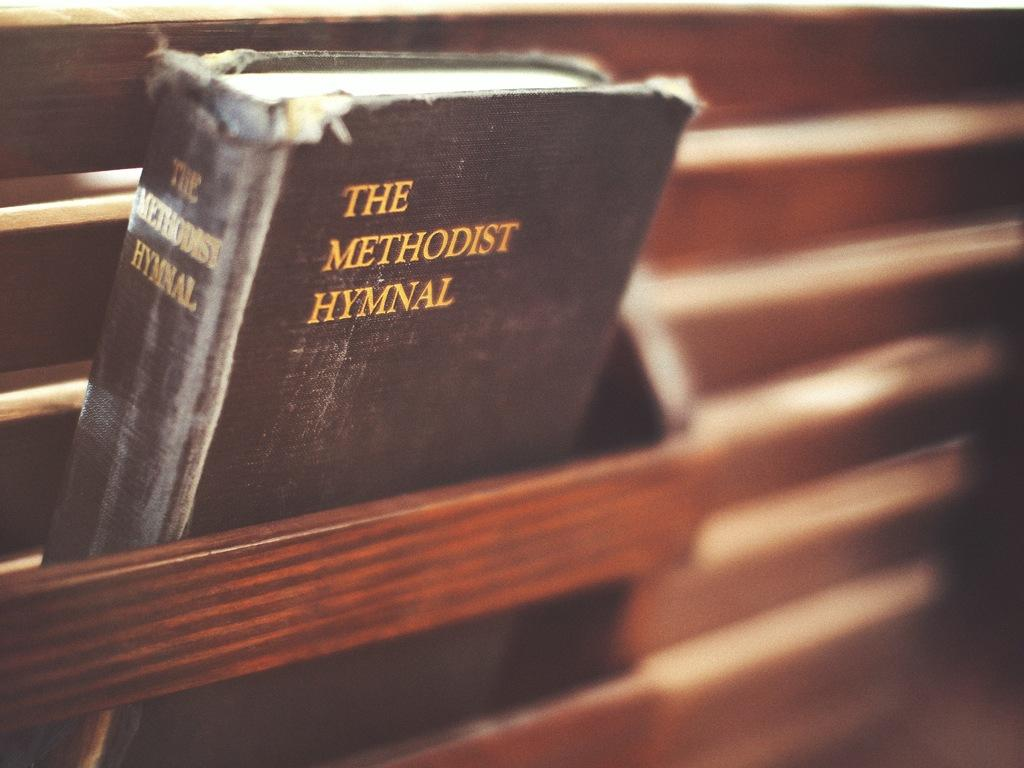Provide a one-sentence caption for the provided image. An old black book titled The Methodist Hymnal. 